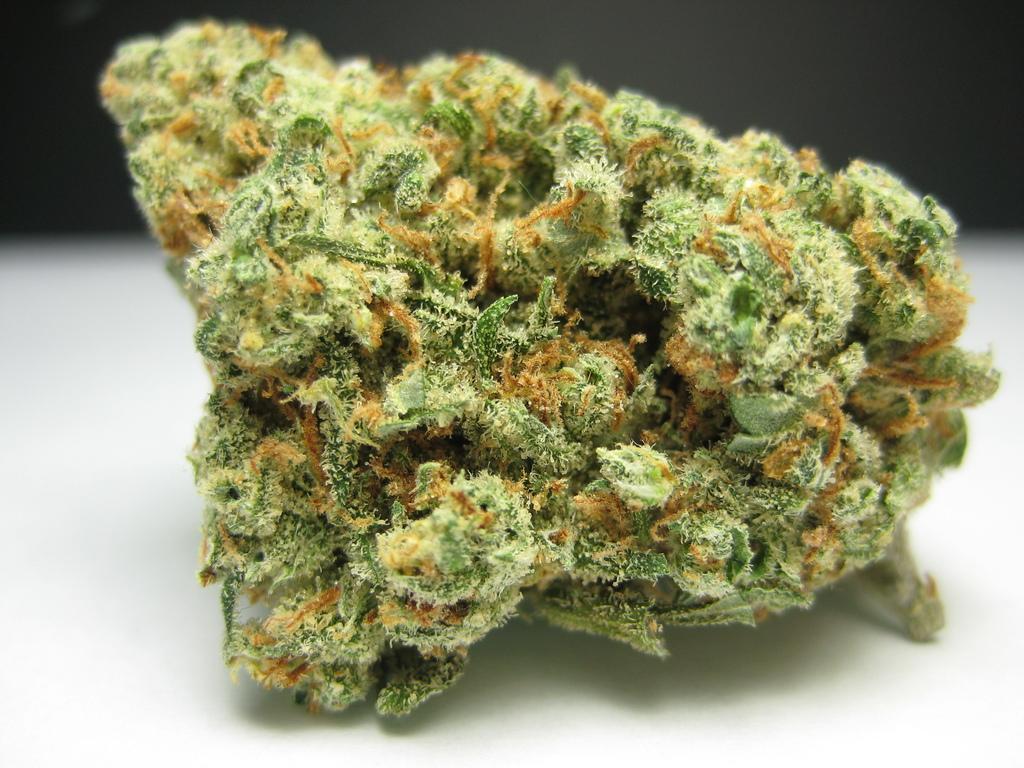Please provide a concise description of this image. Here we can see an item with green color fungus kind of a thing on it on a platform. 